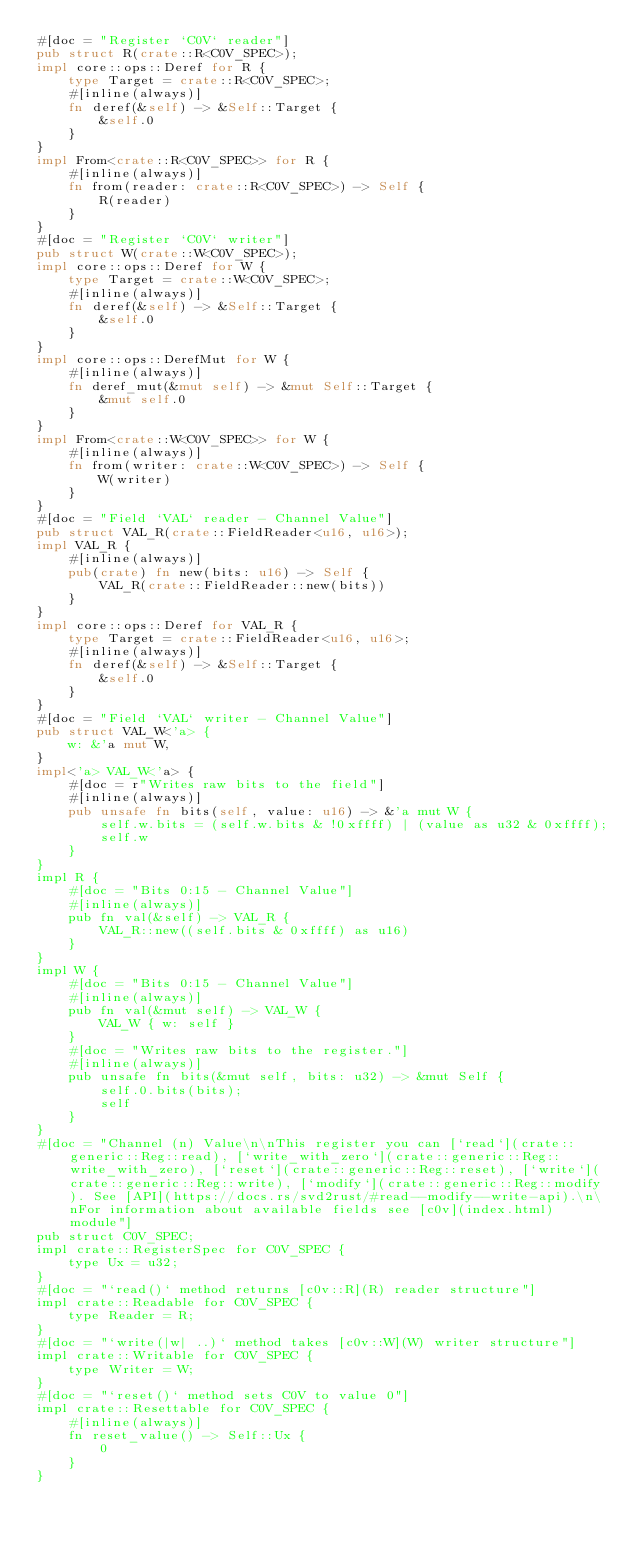<code> <loc_0><loc_0><loc_500><loc_500><_Rust_>#[doc = "Register `C0V` reader"]
pub struct R(crate::R<C0V_SPEC>);
impl core::ops::Deref for R {
    type Target = crate::R<C0V_SPEC>;
    #[inline(always)]
    fn deref(&self) -> &Self::Target {
        &self.0
    }
}
impl From<crate::R<C0V_SPEC>> for R {
    #[inline(always)]
    fn from(reader: crate::R<C0V_SPEC>) -> Self {
        R(reader)
    }
}
#[doc = "Register `C0V` writer"]
pub struct W(crate::W<C0V_SPEC>);
impl core::ops::Deref for W {
    type Target = crate::W<C0V_SPEC>;
    #[inline(always)]
    fn deref(&self) -> &Self::Target {
        &self.0
    }
}
impl core::ops::DerefMut for W {
    #[inline(always)]
    fn deref_mut(&mut self) -> &mut Self::Target {
        &mut self.0
    }
}
impl From<crate::W<C0V_SPEC>> for W {
    #[inline(always)]
    fn from(writer: crate::W<C0V_SPEC>) -> Self {
        W(writer)
    }
}
#[doc = "Field `VAL` reader - Channel Value"]
pub struct VAL_R(crate::FieldReader<u16, u16>);
impl VAL_R {
    #[inline(always)]
    pub(crate) fn new(bits: u16) -> Self {
        VAL_R(crate::FieldReader::new(bits))
    }
}
impl core::ops::Deref for VAL_R {
    type Target = crate::FieldReader<u16, u16>;
    #[inline(always)]
    fn deref(&self) -> &Self::Target {
        &self.0
    }
}
#[doc = "Field `VAL` writer - Channel Value"]
pub struct VAL_W<'a> {
    w: &'a mut W,
}
impl<'a> VAL_W<'a> {
    #[doc = r"Writes raw bits to the field"]
    #[inline(always)]
    pub unsafe fn bits(self, value: u16) -> &'a mut W {
        self.w.bits = (self.w.bits & !0xffff) | (value as u32 & 0xffff);
        self.w
    }
}
impl R {
    #[doc = "Bits 0:15 - Channel Value"]
    #[inline(always)]
    pub fn val(&self) -> VAL_R {
        VAL_R::new((self.bits & 0xffff) as u16)
    }
}
impl W {
    #[doc = "Bits 0:15 - Channel Value"]
    #[inline(always)]
    pub fn val(&mut self) -> VAL_W {
        VAL_W { w: self }
    }
    #[doc = "Writes raw bits to the register."]
    #[inline(always)]
    pub unsafe fn bits(&mut self, bits: u32) -> &mut Self {
        self.0.bits(bits);
        self
    }
}
#[doc = "Channel (n) Value\n\nThis register you can [`read`](crate::generic::Reg::read), [`write_with_zero`](crate::generic::Reg::write_with_zero), [`reset`](crate::generic::Reg::reset), [`write`](crate::generic::Reg::write), [`modify`](crate::generic::Reg::modify). See [API](https://docs.rs/svd2rust/#read--modify--write-api).\n\nFor information about available fields see [c0v](index.html) module"]
pub struct C0V_SPEC;
impl crate::RegisterSpec for C0V_SPEC {
    type Ux = u32;
}
#[doc = "`read()` method returns [c0v::R](R) reader structure"]
impl crate::Readable for C0V_SPEC {
    type Reader = R;
}
#[doc = "`write(|w| ..)` method takes [c0v::W](W) writer structure"]
impl crate::Writable for C0V_SPEC {
    type Writer = W;
}
#[doc = "`reset()` method sets C0V to value 0"]
impl crate::Resettable for C0V_SPEC {
    #[inline(always)]
    fn reset_value() -> Self::Ux {
        0
    }
}
</code> 